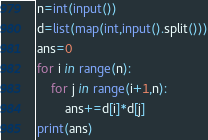Convert code to text. <code><loc_0><loc_0><loc_500><loc_500><_Python_>n=int(input())
d=list(map(int,input().split()))
ans=0
for i in range(n):
    for j in range(i+1,n):
        ans+=d[i]*d[j]
print(ans)

</code> 